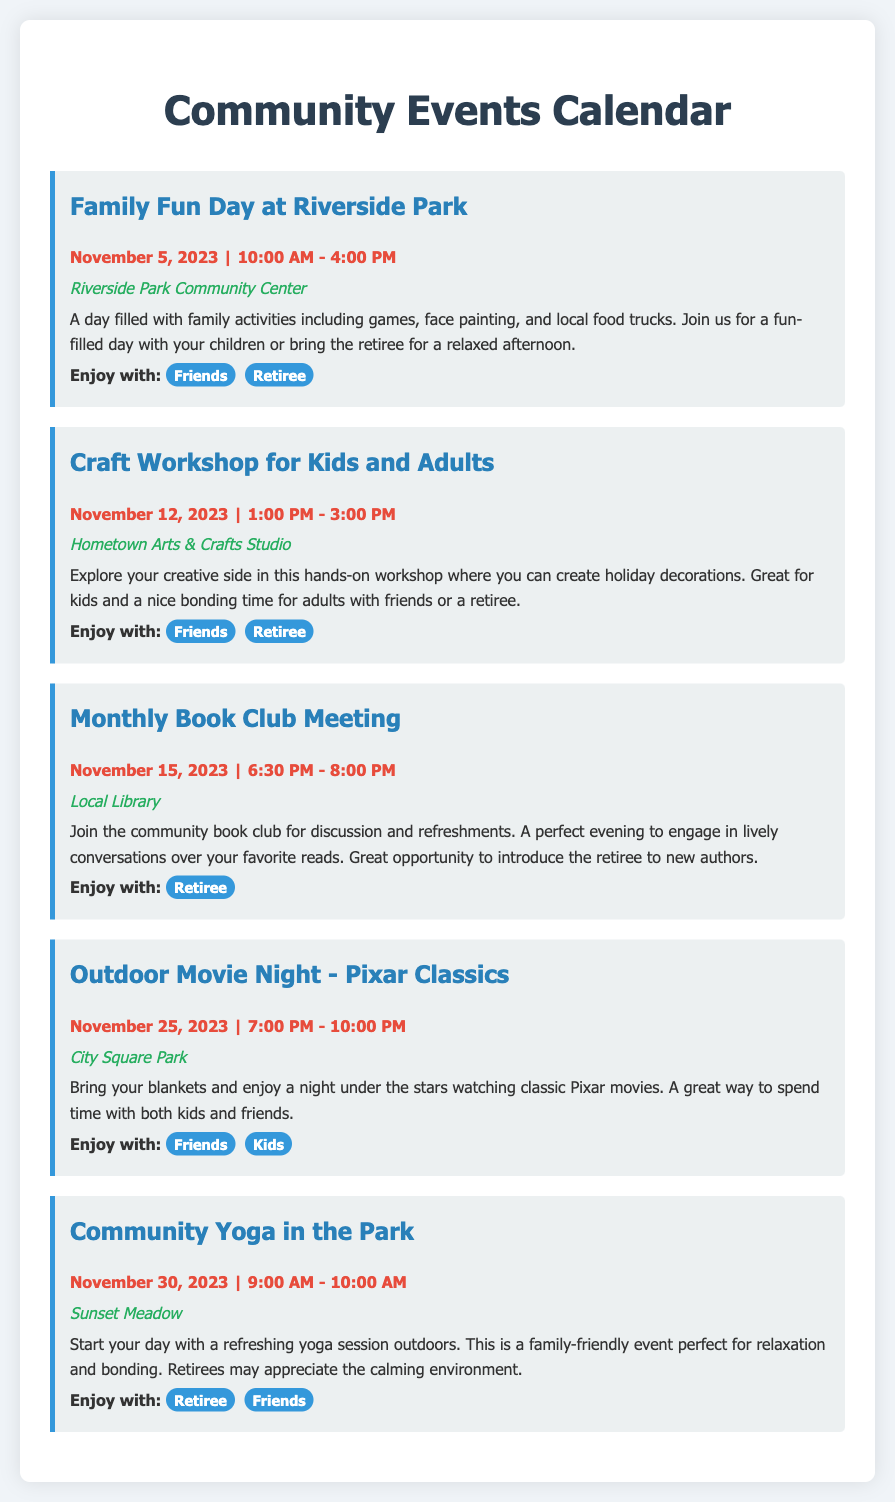what is the title of the first event? The title of the first event is the name given to it, which is "Family Fun Day at Riverside Park."
Answer: Family Fun Day at Riverside Park when is the Outdoor Movie Night scheduled? The schedule for the Outdoor Movie Night can be found in the date section of the document, which lists it as November 25, 2023.
Answer: November 25, 2023 where is the Craft Workshop for Kids and Adults taking place? The document specifies the location for the Craft Workshop, which is at "Hometown Arts & Crafts Studio."
Answer: Hometown Arts & Crafts Studio which event is suitable to attend with a retiree only? The reasoning requires looking at the "Enjoy with" section of events; the Monthly Book Club Meeting is marked for "Retiree."
Answer: Monthly Book Club Meeting how many events are mentioned in the document? The total number of described events can be counted directly within the document; there are five events listed.
Answer: 5 what is the starting time for Community Yoga in the Park? The starting time is listed in the date-time section of the event, which states it starts at 9:00 AM.
Answer: 9:00 AM which events are categorized as family-friendly? To determine family-friendly events, you must look at each event description; the Family Fun Day, Outdoor Movie Night, and Community Yoga are noted as family-friendly.
Answer: Family Fun Day, Outdoor Movie Night, Community Yoga what type of event is happening on November 12, 2023? By referring to the date for this specific event, it is identified as a "Craft Workshop for Kids and Adults."
Answer: Craft Workshop for Kids and Adults 